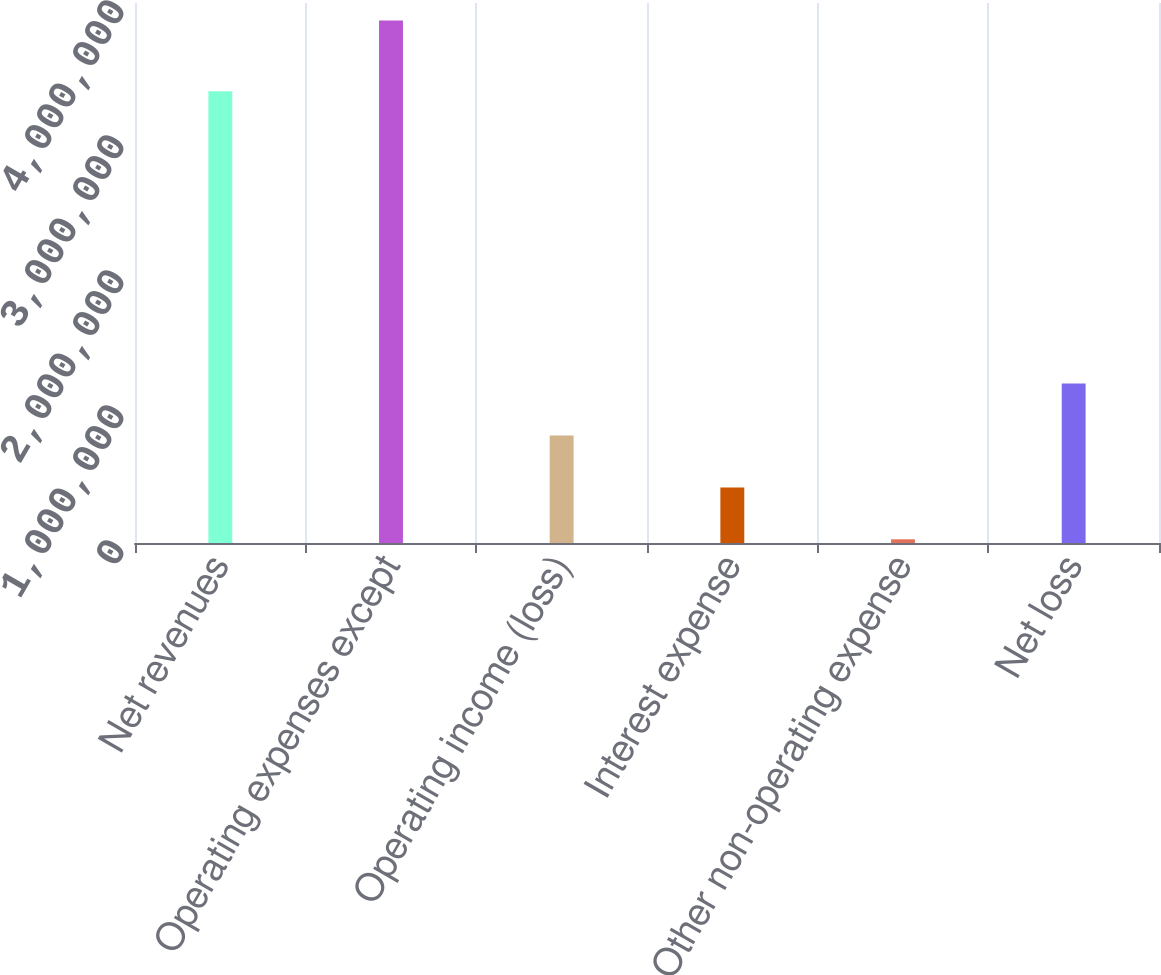<chart> <loc_0><loc_0><loc_500><loc_500><bar_chart><fcel>Net revenues<fcel>Operating expenses except<fcel>Operating income (loss)<fcel>Interest expense<fcel>Other non-operating expense<fcel>Net loss<nl><fcel>3.34563e+06<fcel>3.87124e+06<fcel>796209<fcel>411830<fcel>27451<fcel>1.18059e+06<nl></chart> 